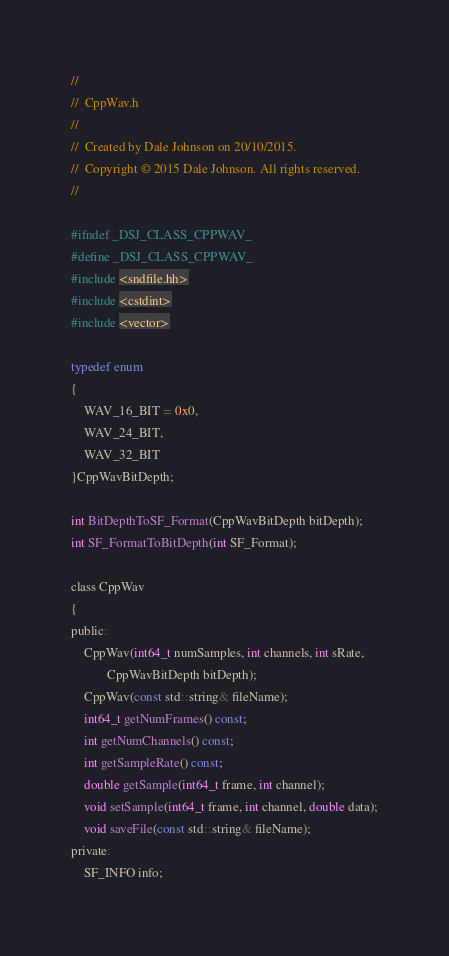<code> <loc_0><loc_0><loc_500><loc_500><_C_>//
//  CppWav.h
//
//  Created by Dale Johnson on 20/10/2015.
//  Copyright © 2015 Dale Johnson. All rights reserved.
//

#ifndef _DSJ_CLASS_CPPWAV_
#define _DSJ_CLASS_CPPWAV_
#include <sndfile.hh>
#include <cstdint>
#include <vector>

typedef enum
{
    WAV_16_BIT = 0x0,
    WAV_24_BIT,
    WAV_32_BIT
}CppWavBitDepth;

int BitDepthToSF_Format(CppWavBitDepth bitDepth);
int SF_FormatToBitDepth(int SF_Format);

class CppWav
{
public:
    CppWav(int64_t numSamples, int channels, int sRate,
           CppWavBitDepth bitDepth);
    CppWav(const std::string& fileName);
    int64_t getNumFrames() const;
    int getNumChannels() const;
    int getSampleRate() const;
    double getSample(int64_t frame, int channel);
    void setSample(int64_t frame, int channel, double data);
    void saveFile(const std::string& fileName);
private:
    SF_INFO info;</code> 